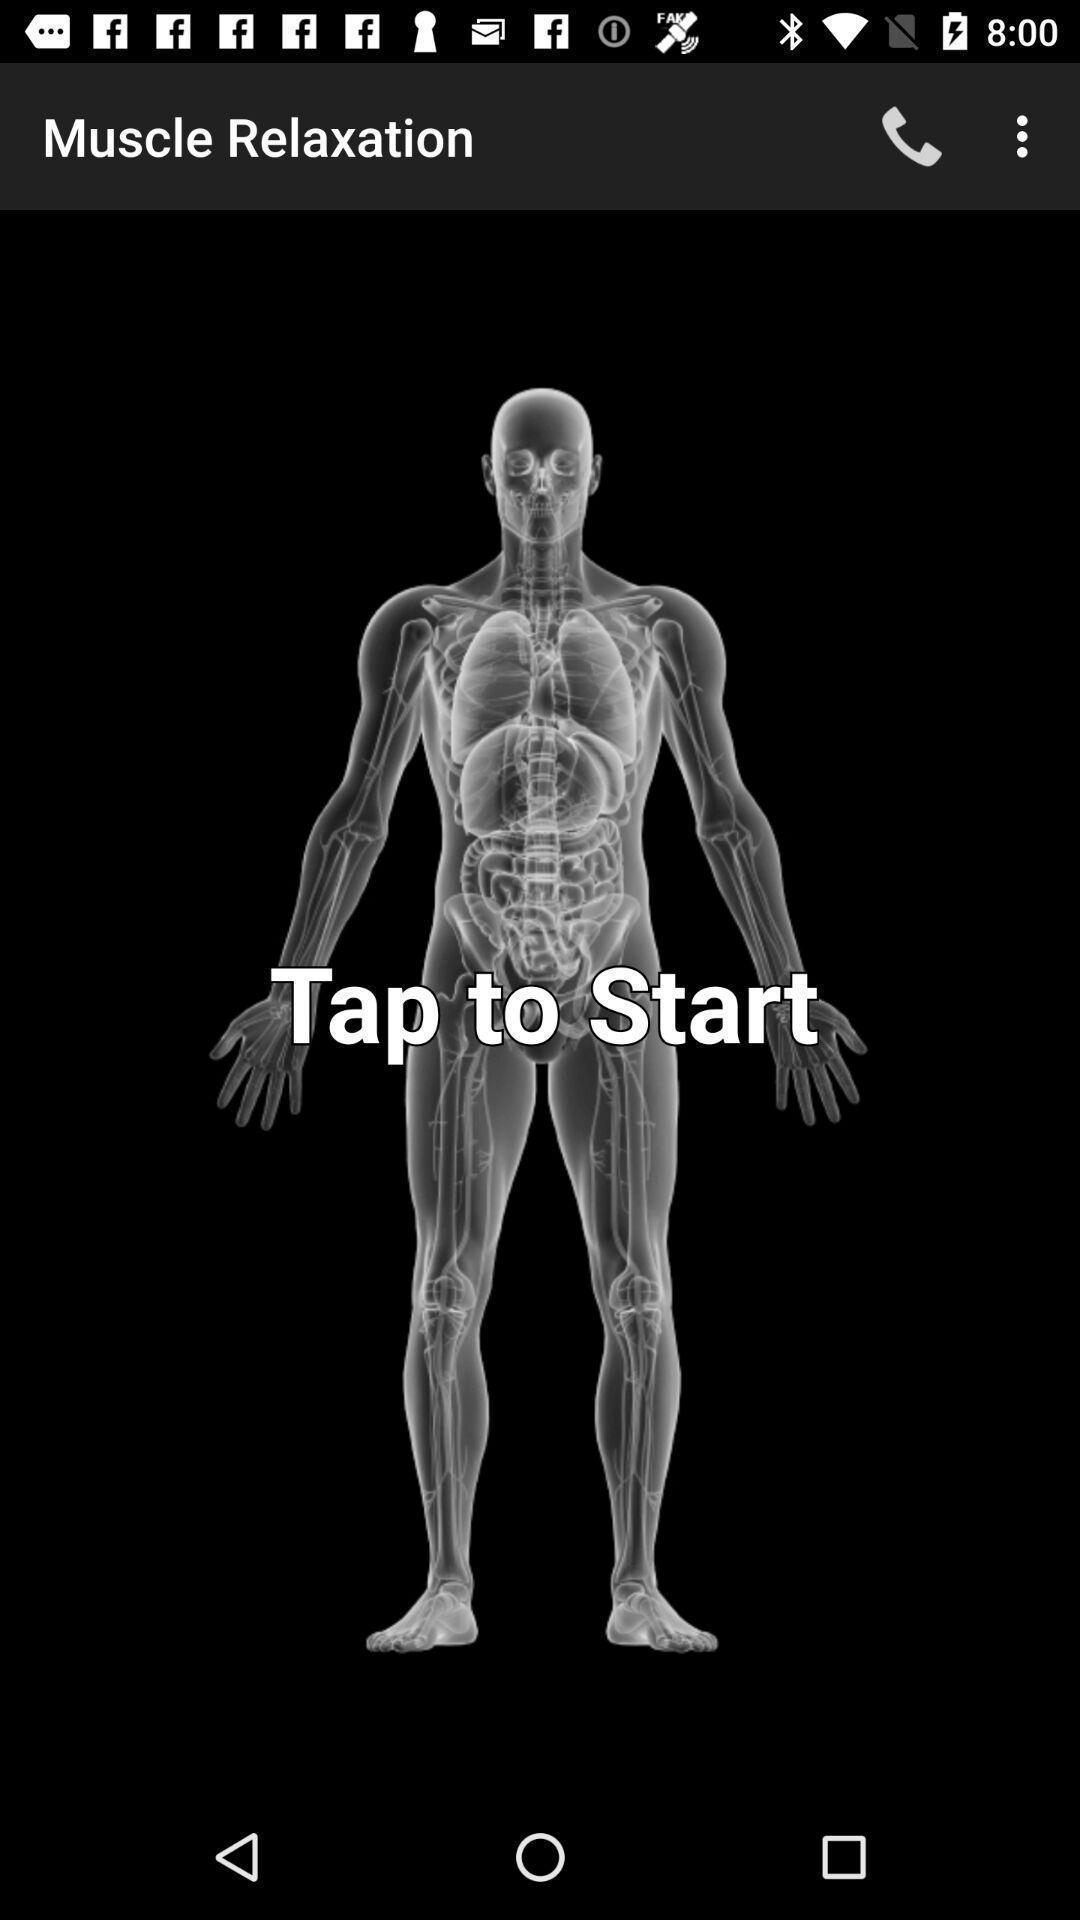Provide a description of this screenshot. Start page. 